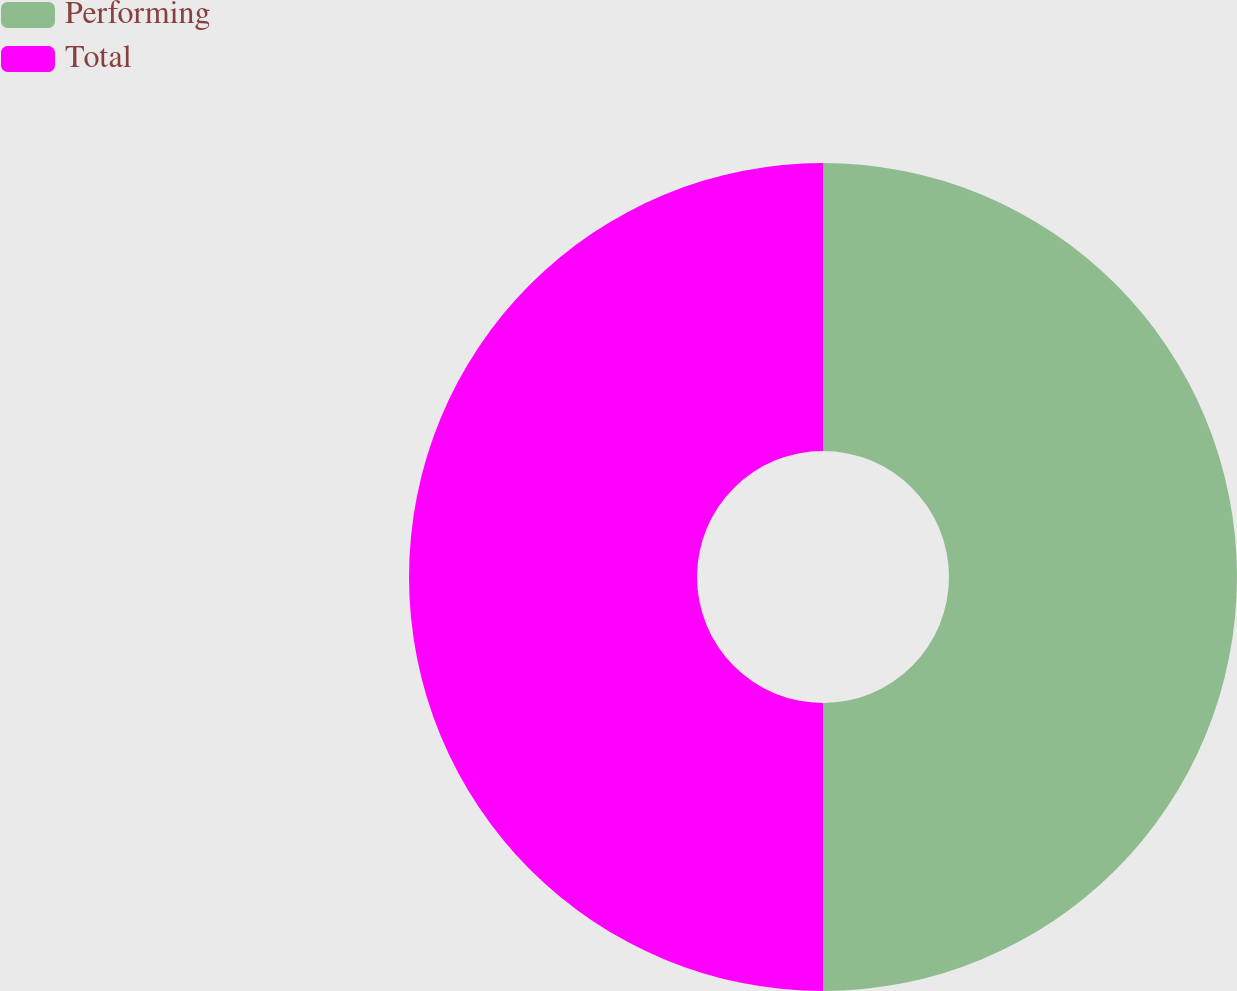Convert chart. <chart><loc_0><loc_0><loc_500><loc_500><pie_chart><fcel>Performing<fcel>Total<nl><fcel>50.0%<fcel>50.0%<nl></chart> 